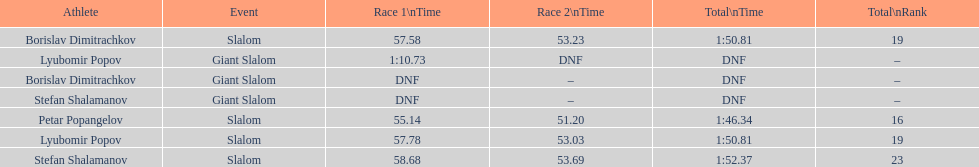Who has the highest rank? Petar Popangelov. 